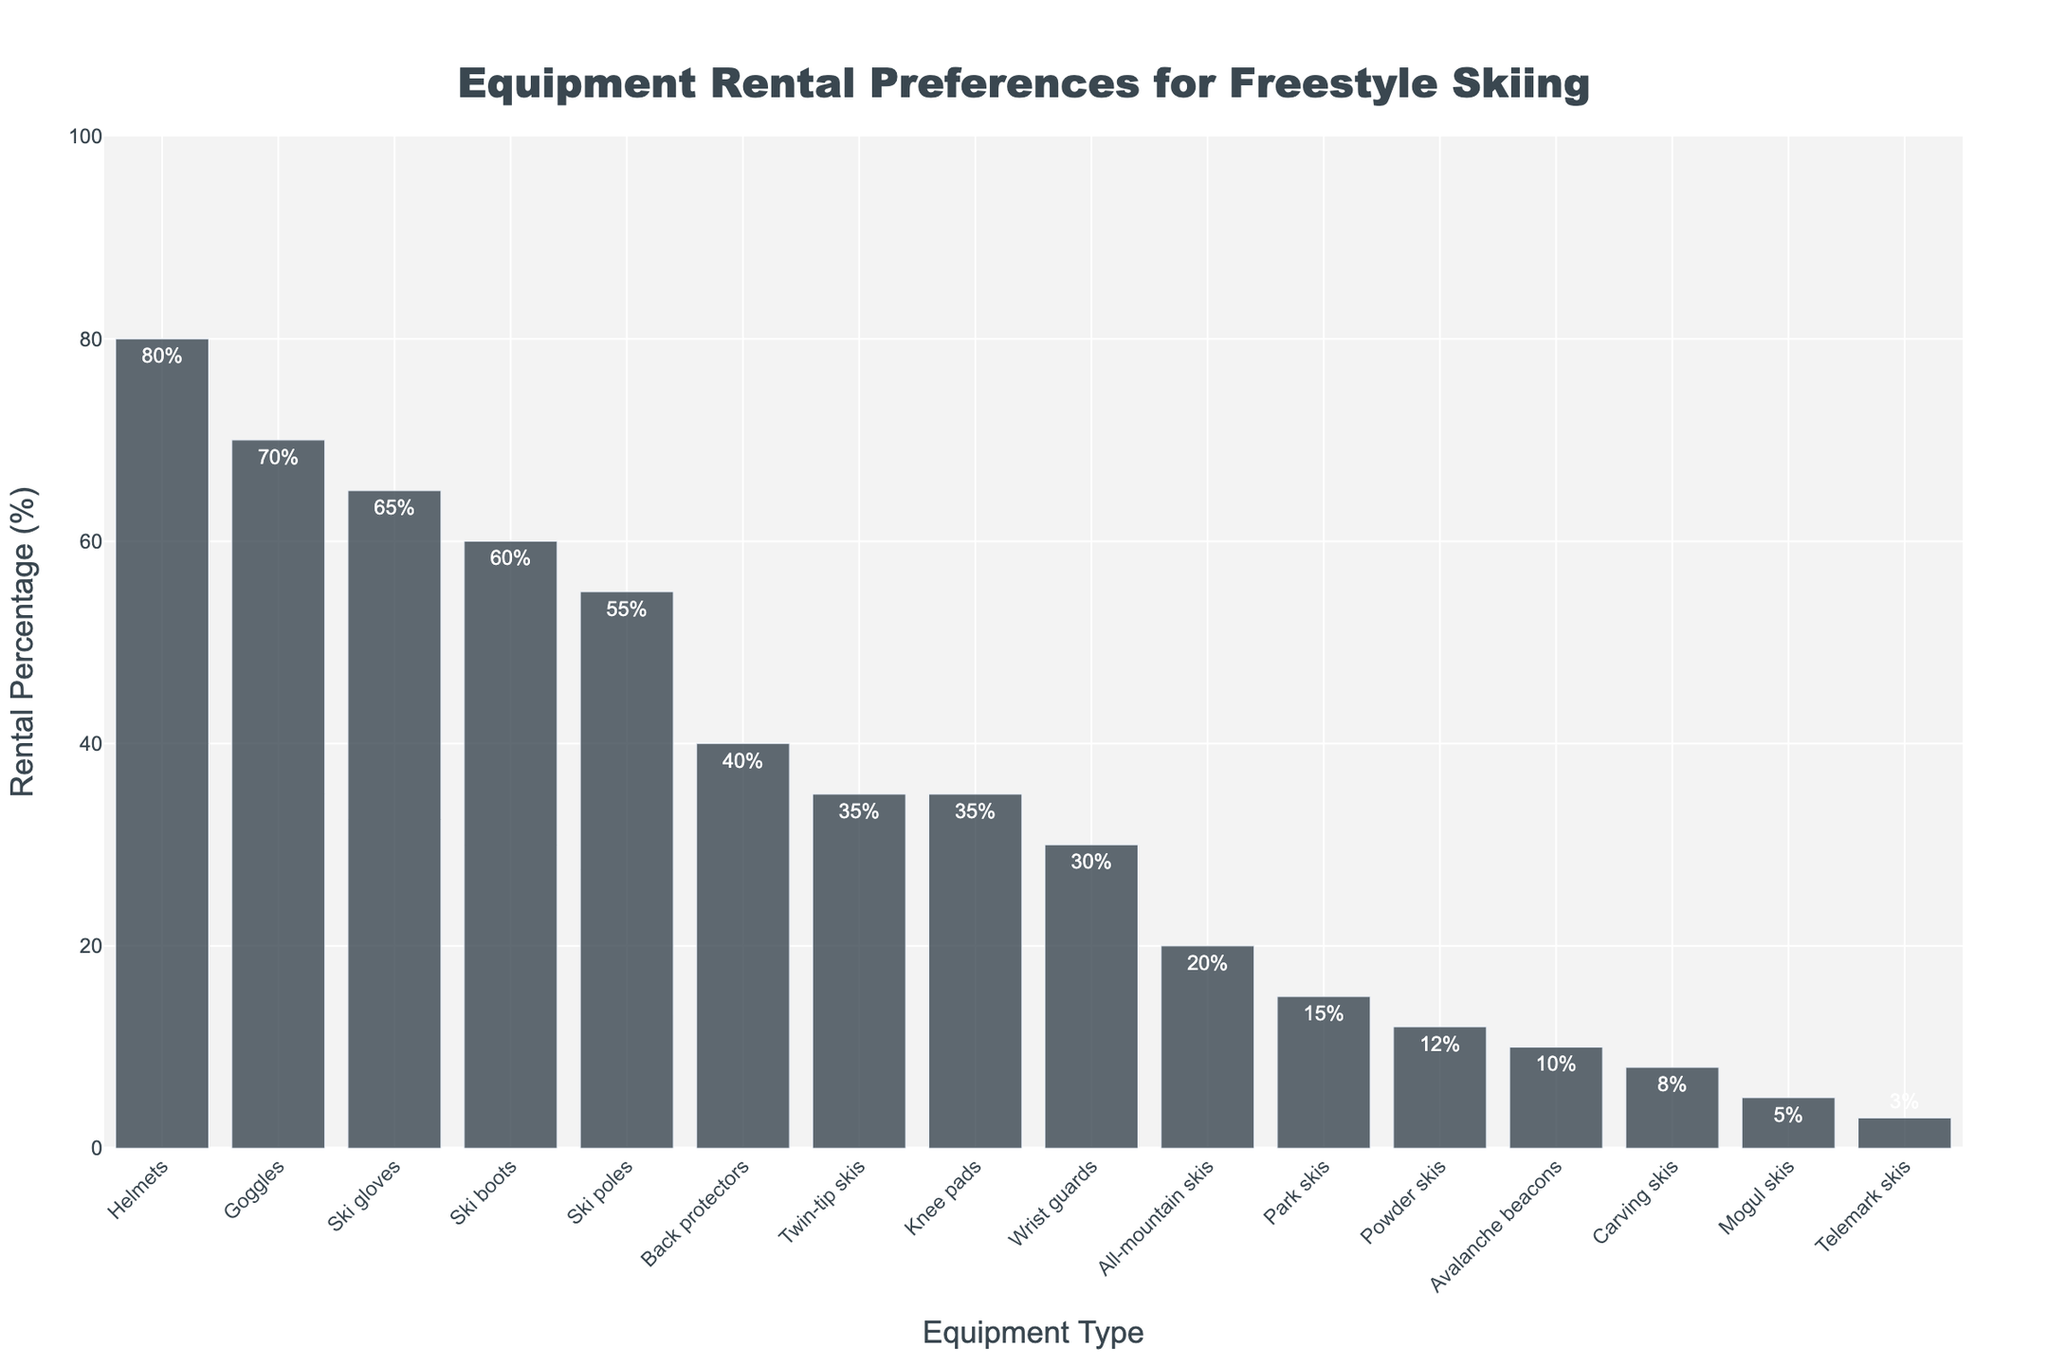Which equipment type has the highest rental percentage? The tallest bar indicates the equipment type with the highest rental percentage. The helmet bar is the tallest.
Answer: Helmets Which two equipment types have the smallest rental percentages? The shortest bars represent the equipment types with the smallest rental percentages. These are telemark skis and avalanche beacons.
Answer: Telemark skis and avalanche beacons How much greater is the rental percentage for ski gloves compared to ski poles? Find the rental percentages for ski gloves and ski poles. Then subtract the smaller percentage from the larger one (65% - 55%).
Answer: 10% What is the average rental percentage of all ski equipment (excluding accessories like helmets and gloves)? Sum the rental percentages of all ski equipment (Twin-tip skis, All-mountain skis, Park skis, Powder skis, Carving skis, Mogul skis, and Telemark skis) and divide by 7. ((35+20+15+12+8+5+3)/7).
Answer: 14% Which equipment type has a rental percentage closest to 50%? Look for the bar closest to the 50% mark. Ski poles have a rental percentage of 55%, closest to 50%.
Answer: Ski poles How much higher is the rental percentage for twin-tip skis compared to carving skis? Subtract the rental percentage of carving skis from twin-tip skis (35% - 8%).
Answer: 27% What is the total rental percentage for all protective equipment (helmets, back protectors, knee pads, wrist guards, and avalanche beacons)? Add the rental percentages for all protective equipment (80% + 40% + 35% + 30% + 10%).
Answer: 195% Compare the rental percentages of park skis and powder skis. Which one is higher and by how much? Identify the rental percentages of park skis and powder skis, and then find the difference (15% - 12%).
Answer: Park skis by 3% What is the difference between the highest and the lowest rental percentages? Subtract the smallest percentage (telemark skis) from the largest percentage (helmets) (80% - 3%).
Answer: 77% Which equipment type appears first alphabetically but has a rental percentage over 50%? Start with the alphabetical order and find the first equipment type whose rental percentage is above 50%. Goggles appear first and have a percentage of 70%.
Answer: Goggles 